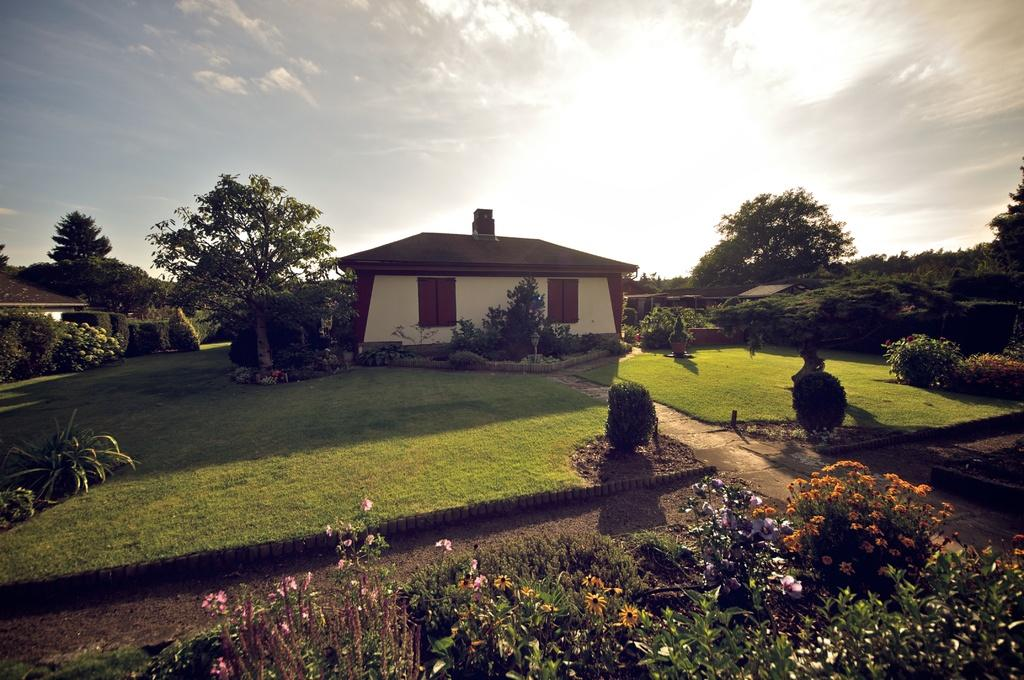What type of plants can be seen in the image? There are plants with flowers in the image. What type of vegetation is present on the ground in the image? There is grass in the image. What type of tall vegetation is present in the image? There are trees in the image. What type of structures can be seen in the image? There are houses in the image. What is visible in the background of the image? The sky is visible in the background of the image. How many rabbits are hopping through the grass in the image? There are no rabbits present in the image. What type of system is responsible for the growth of the plants in the image? The image does not provide information about a system responsible for the growth of the plants. 